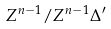<formula> <loc_0><loc_0><loc_500><loc_500>Z ^ { n - 1 } / Z ^ { n - 1 } \Delta ^ { \prime }</formula> 